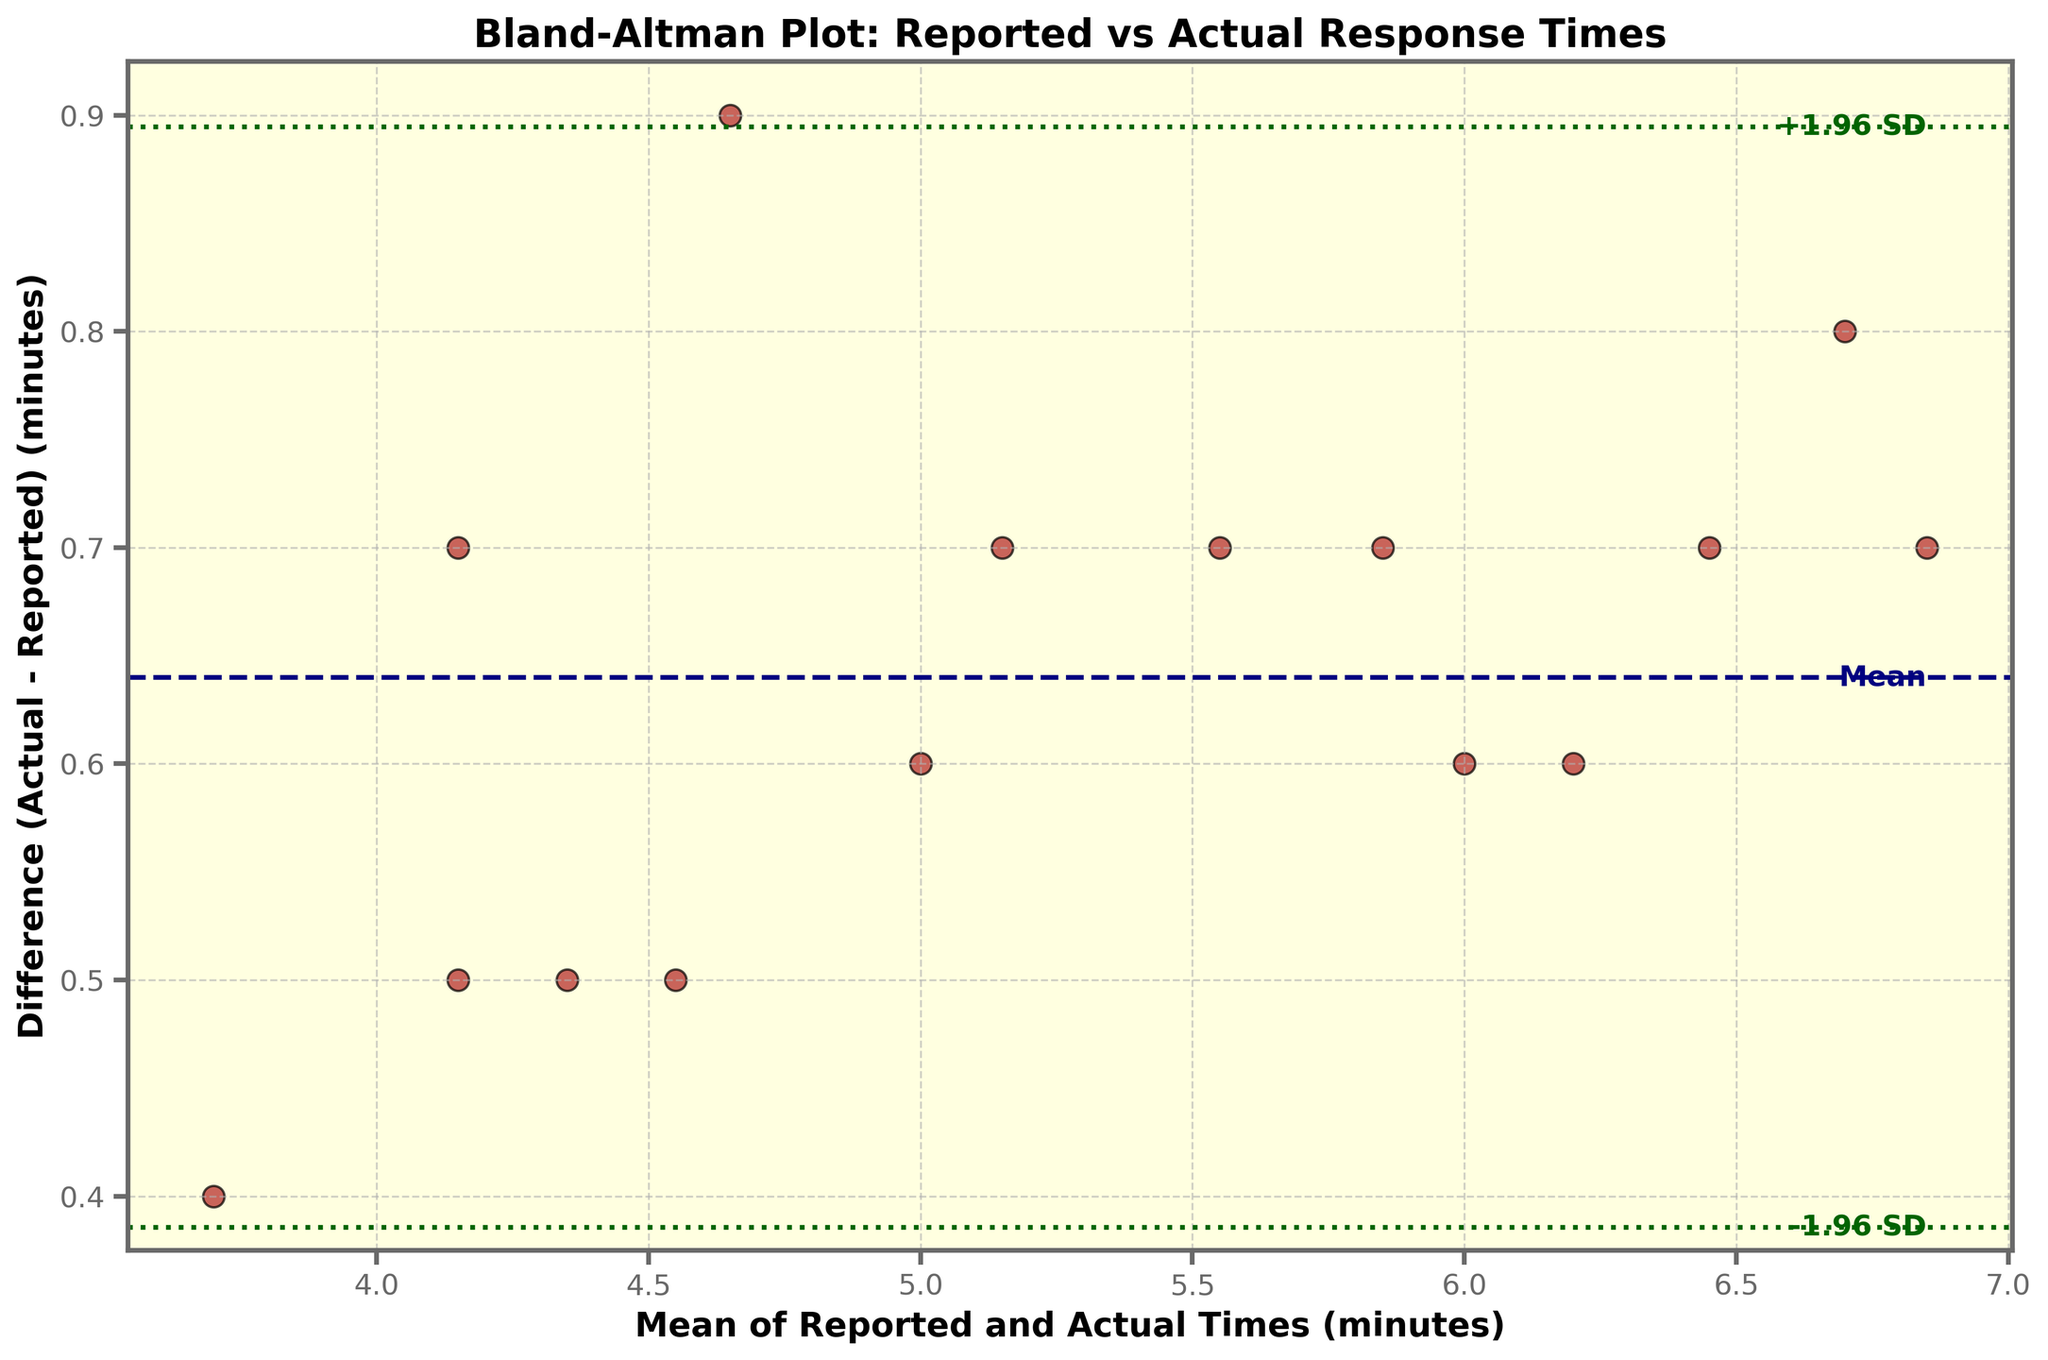What is the title of the figure? The title is displayed at the top of the figure. It reads "Bland-Altman Plot: Reported vs Actual Response Times"
Answer: Bland-Altman Plot: Reported vs Actual Response Times What does the x-axis label indicate? The x-axis label is located below the horizontal axis. It describes the variable on the x-axis, which is "Mean of Reported and Actual Times (minutes)"
Answer: Mean of Reported and Actual Times (minutes) What is the color of the horizontal line representing the mean difference? The horizontal line representing the mean difference is colored in a visible color. This line is "navy" in the plot.
Answer: navy How many data points are displayed in the figure? Each data point is represented by a scatter plot marker. By counting the markers in the figure, you can see that there are 15 data points.
Answer: 15 What values do the green dashed lines represent? The green dashed lines represent the limits of agreement which are set at ±1.96 standard deviations from the mean difference. These values can be located by looking at their intersection points on the y-axis.
Answer: Limits of agreement Which response time had the largest mean value? By comparing the means of each point in the scatter plot, the largest recorded can be determined. The point farthest to the right on the x-axis represents the largest mean value. This points corresponds to "7.1".
Answer: 7.1 Which response time had the smallest mean value? The smallest mean value is determined by finding the point farthest to the left on the x-axis. This corresponds to the mean of "3.65".
Answer: 3.65 Is there a firefighter team whose difference is zero? A difference of zero would be indicated by a data point lying exactly on the mean difference line. Observing the plot, no data point is at zero, which means no team has a zero difference in response time.
Answer: No Which team had the highest difference between reported and actual response times? The highest difference in response times can be identified by the data point that is farthest from the mean difference line and located in the y-axis direction. This point corresponds to a difference identified for "Rescue 3, 7.1".
Answer: Rescue 3, 7.1 Which team had the lowest difference between reported and actual response times? The lowest difference is the point nearest to the mean difference line that isn’t zero. The point with the smallest deviation from the mean difference represents the lowest difference, corresponding to "Engine 8, 3.9".
Answer: Engine 8, 3.9 